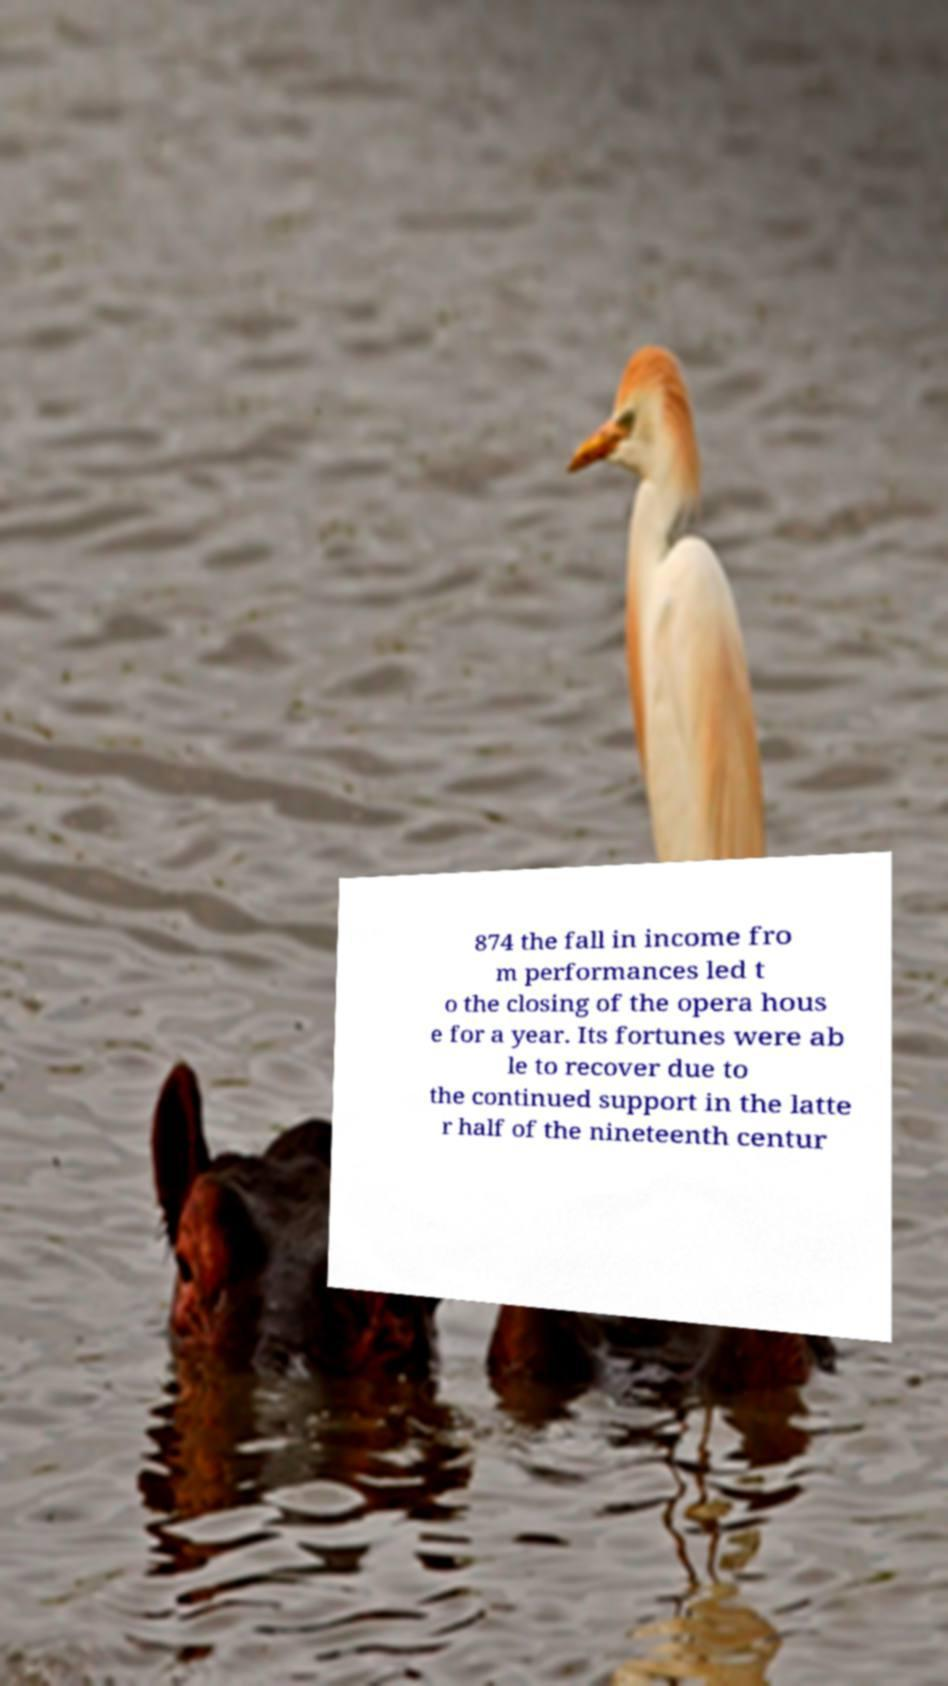Please read and relay the text visible in this image. What does it say? 874 the fall in income fro m performances led t o the closing of the opera hous e for a year. Its fortunes were ab le to recover due to the continued support in the latte r half of the nineteenth centur 